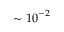Convert formula to latex. <formula><loc_0><loc_0><loc_500><loc_500>\sim { 1 0 } ^ { - 2 }</formula> 